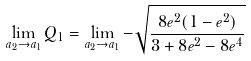<formula> <loc_0><loc_0><loc_500><loc_500>\lim _ { a _ { 2 } \to a _ { 1 } } Q _ { 1 } = \lim _ { a _ { 2 } \to a _ { 1 } } - \sqrt { \frac { 8 e ^ { 2 } ( 1 - e ^ { 2 } ) } { 3 + 8 e ^ { 2 } - 8 e ^ { 4 } } }</formula> 